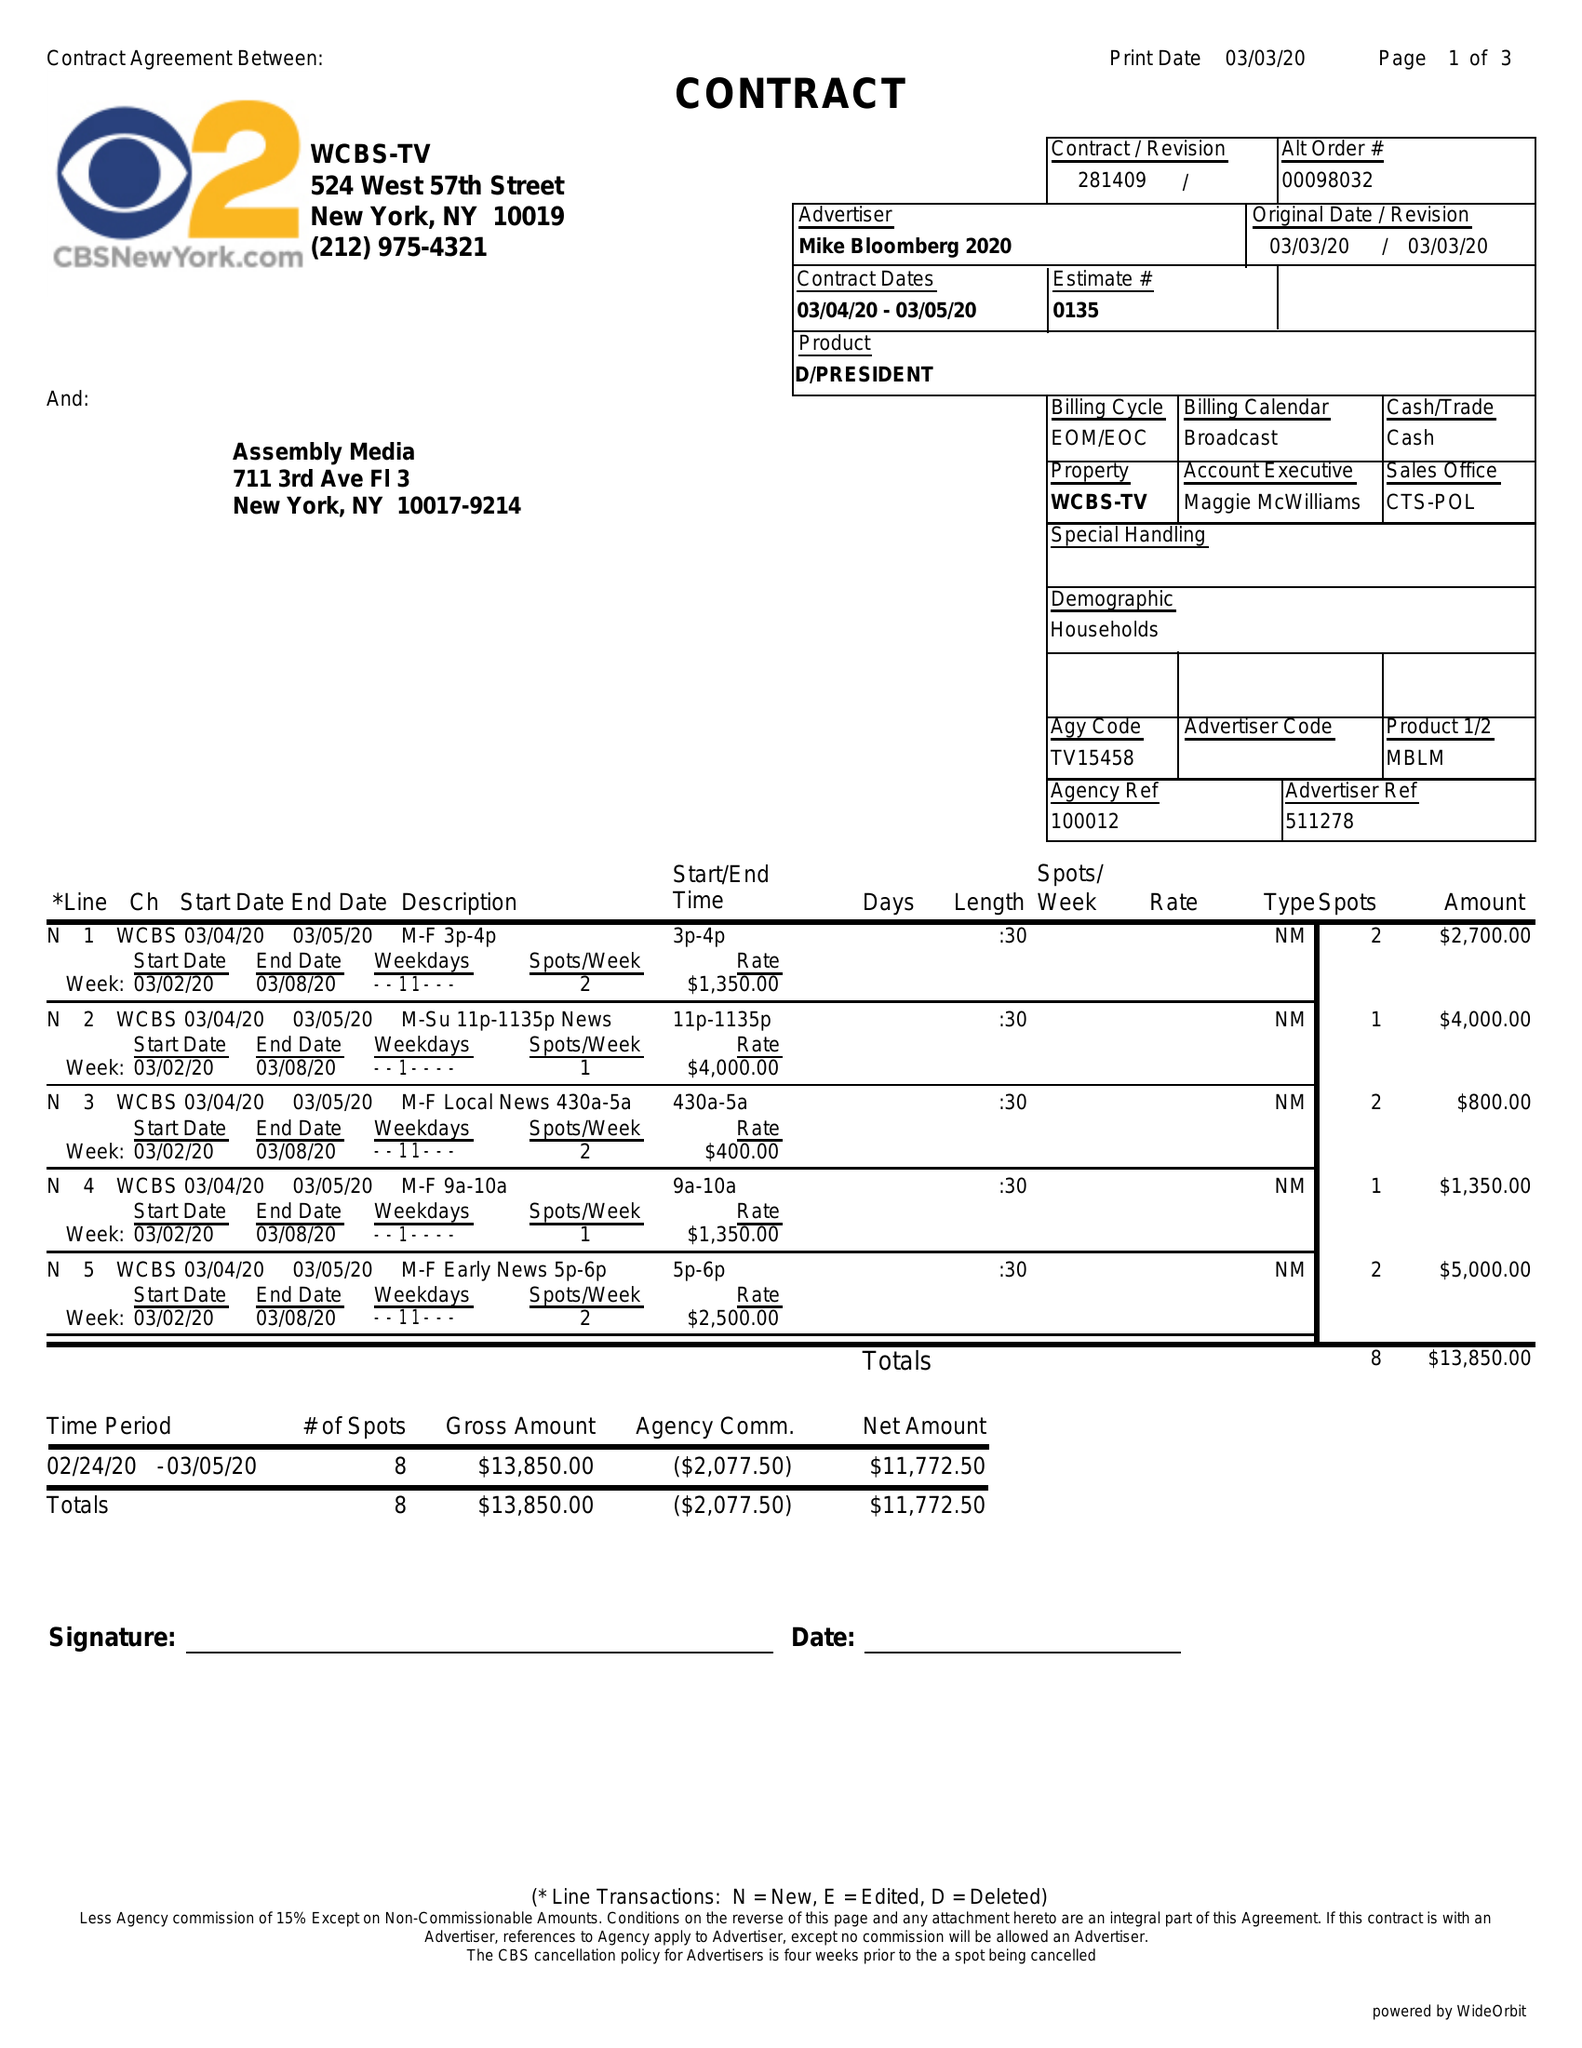What is the value for the advertiser?
Answer the question using a single word or phrase. MIKE BLOOMBERG 2020 